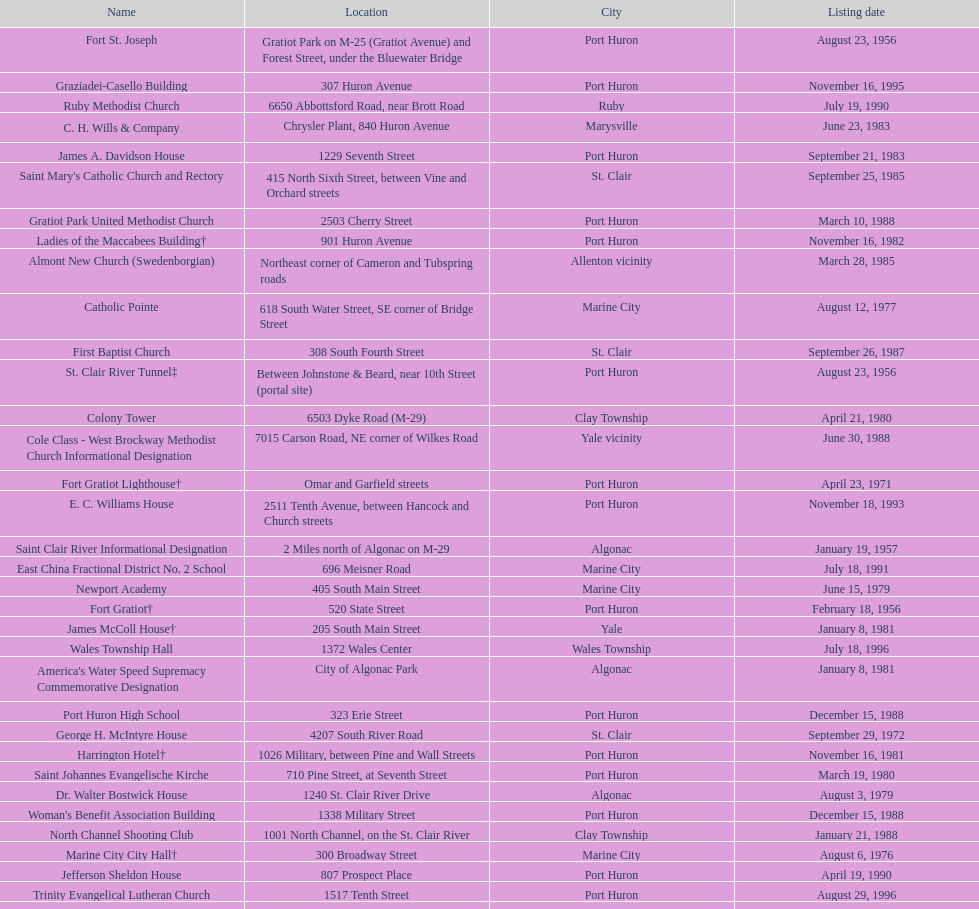What is the total number of locations in the city of algonac? 5. Could you help me parse every detail presented in this table? {'header': ['Name', 'Location', 'City', 'Listing date'], 'rows': [['Fort St. Joseph', 'Gratiot Park on M-25 (Gratiot Avenue) and Forest Street, under the Bluewater Bridge', 'Port Huron', 'August 23, 1956'], ['Graziadei-Casello Building', '307 Huron Avenue', 'Port Huron', 'November 16, 1995'], ['Ruby Methodist Church', '6650 Abbottsford Road, near Brott Road', 'Ruby', 'July 19, 1990'], ['C. H. Wills & Company', 'Chrysler Plant, 840 Huron Avenue', 'Marysville', 'June 23, 1983'], ['James A. Davidson House', '1229 Seventh Street', 'Port Huron', 'September 21, 1983'], ["Saint Mary's Catholic Church and Rectory", '415 North Sixth Street, between Vine and Orchard streets', 'St. Clair', 'September 25, 1985'], ['Gratiot Park United Methodist Church', '2503 Cherry Street', 'Port Huron', 'March 10, 1988'], ['Ladies of the Maccabees Building†', '901 Huron Avenue', 'Port Huron', 'November 16, 1982'], ['Almont New Church (Swedenborgian)', 'Northeast corner of Cameron and Tubspring roads', 'Allenton vicinity', 'March 28, 1985'], ['Catholic Pointe', '618 South Water Street, SE corner of Bridge Street', 'Marine City', 'August 12, 1977'], ['First Baptist Church', '308 South Fourth Street', 'St. Clair', 'September 26, 1987'], ['St. Clair River Tunnel‡', 'Between Johnstone & Beard, near 10th Street (portal site)', 'Port Huron', 'August 23, 1956'], ['Colony Tower', '6503 Dyke Road (M-29)', 'Clay Township', 'April 21, 1980'], ['Cole Class - West Brockway Methodist Church Informational Designation', '7015 Carson Road, NE corner of Wilkes Road', 'Yale vicinity', 'June 30, 1988'], ['Fort Gratiot Lighthouse†', 'Omar and Garfield streets', 'Port Huron', 'April 23, 1971'], ['E. C. Williams House', '2511 Tenth Avenue, between Hancock and Church streets', 'Port Huron', 'November 18, 1993'], ['Saint Clair River Informational Designation', '2 Miles north of Algonac on M-29', 'Algonac', 'January 19, 1957'], ['East China Fractional District No. 2 School', '696 Meisner Road', 'Marine City', 'July 18, 1991'], ['Newport Academy', '405 South Main Street', 'Marine City', 'June 15, 1979'], ['Fort Gratiot†', '520 State Street', 'Port Huron', 'February 18, 1956'], ['James McColl House†', '205 South Main Street', 'Yale', 'January 8, 1981'], ['Wales Township Hall', '1372 Wales Center', 'Wales Township', 'July 18, 1996'], ["America's Water Speed Supremacy Commemorative Designation", 'City of Algonac Park', 'Algonac', 'January 8, 1981'], ['Port Huron High School', '323 Erie Street', 'Port Huron', 'December 15, 1988'], ['George H. McIntyre House', '4207 South River Road', 'St. Clair', 'September 29, 1972'], ['Harrington Hotel†', '1026 Military, between Pine and Wall Streets', 'Port Huron', 'November 16, 1981'], ['Saint Johannes Evangelische Kirche', '710 Pine Street, at Seventh Street', 'Port Huron', 'March 19, 1980'], ['Dr. Walter Bostwick House', '1240 St. Clair River Drive', 'Algonac', 'August 3, 1979'], ["Woman's Benefit Association Building", '1338 Military Street', 'Port Huron', 'December 15, 1988'], ['North Channel Shooting Club', '1001 North Channel, on the St. Clair River', 'Clay Township', 'January 21, 1988'], ['Marine City City Hall†', '300 Broadway Street', 'Marine City', 'August 6, 1976'], ['Jefferson Sheldon House', '807 Prospect Place', 'Port Huron', 'April 19, 1990'], ['Trinity Evangelical Lutheran Church', '1517 Tenth Street', 'Port Huron', 'August 29, 1996'], ['Congregational Church', '300 Adams St', 'St. Clair', 'August 3, 1979'], ['Algonac City Hall (Demolished)', '1410 St. Clair River Drive', 'Algonac', 'February 7, 1977'], ["Saint Andrew's Episcopal Church", '1507 St. Clair River Drive', 'Algonac', 'January 16, 1990'], ['Wilbur F. Davidson House†', '1707 Military Street', 'Port Huron', 'May 17, 1973'], ['First Baptist Church (Demolished)', 'Erie Square', 'Port Huron', 'August 13, 1971'], ['Saint Clair Inn†', '500 Riverside', 'St. Clair', 'October 20, 1994'], ['Grand Trunk Western Railroad Depot†', '520 State Street', 'Port Huron', 'September 2, 1966'], ['Harsen Home', '2006 Golf Course Road', 'Harsens Island', 'February 7, 1977'], ['Fort Sinclair (20SC58)', 'South of the mouth of the Pine River on the St. Clair River', 'St. Clair', 'February 17, 1965'], ['Lightship No. 103‡', 'Pine Grove Park', 'Port Huron', 'May 17, 1973'], ['Ward-Holland House†', '433 North Main Street', 'Marine City', 'May 5, 1964'], ['Grace Episcopal Church', '1213 Sixth Street', 'Port Huron', 'April 18, 1991']]} 